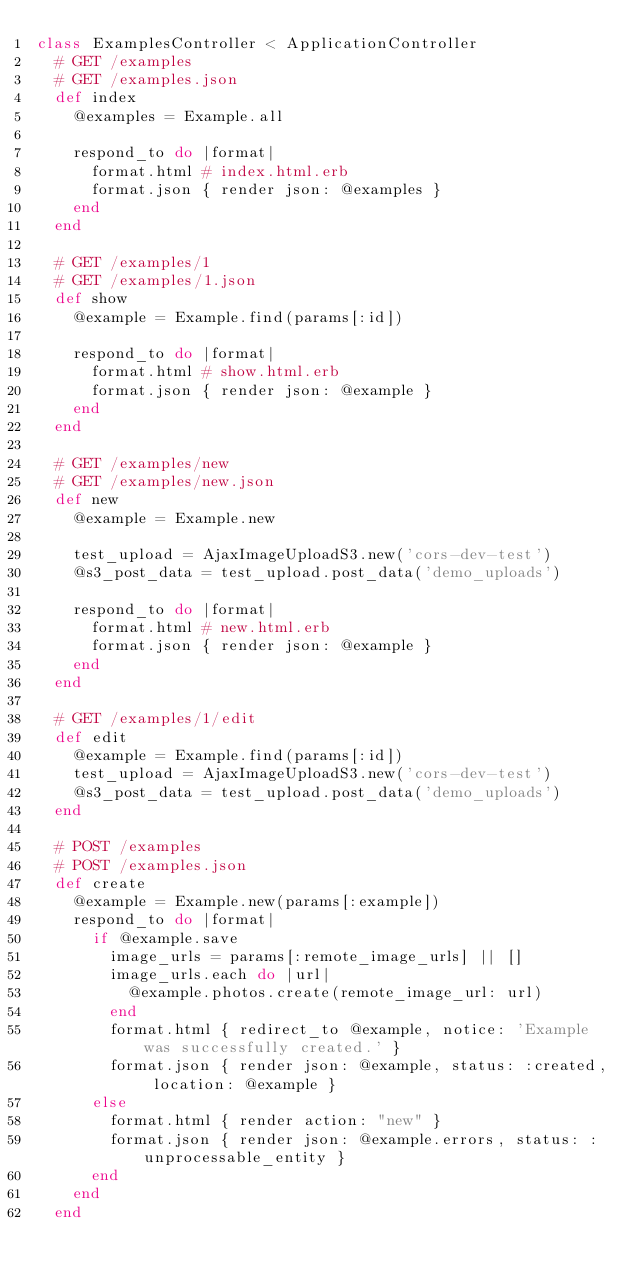Convert code to text. <code><loc_0><loc_0><loc_500><loc_500><_Ruby_>class ExamplesController < ApplicationController
  # GET /examples
  # GET /examples.json
  def index
    @examples = Example.all

    respond_to do |format|
      format.html # index.html.erb
      format.json { render json: @examples }
    end
  end

  # GET /examples/1
  # GET /examples/1.json
  def show
    @example = Example.find(params[:id])

    respond_to do |format|
      format.html # show.html.erb
      format.json { render json: @example }
    end
  end

  # GET /examples/new
  # GET /examples/new.json
  def new
    @example = Example.new

    test_upload = AjaxImageUploadS3.new('cors-dev-test')
    @s3_post_data = test_upload.post_data('demo_uploads')

    respond_to do |format|
      format.html # new.html.erb
      format.json { render json: @example }
    end
  end

  # GET /examples/1/edit
  def edit
    @example = Example.find(params[:id])
    test_upload = AjaxImageUploadS3.new('cors-dev-test')
    @s3_post_data = test_upload.post_data('demo_uploads')
  end

  # POST /examples
  # POST /examples.json
  def create
    @example = Example.new(params[:example])
    respond_to do |format|
      if @example.save
        image_urls = params[:remote_image_urls] || []
        image_urls.each do |url|
          @example.photos.create(remote_image_url: url)
        end
        format.html { redirect_to @example, notice: 'Example was successfully created.' }
        format.json { render json: @example, status: :created, location: @example }
      else
        format.html { render action: "new" }
        format.json { render json: @example.errors, status: :unprocessable_entity }
      end
    end
  end
</code> 